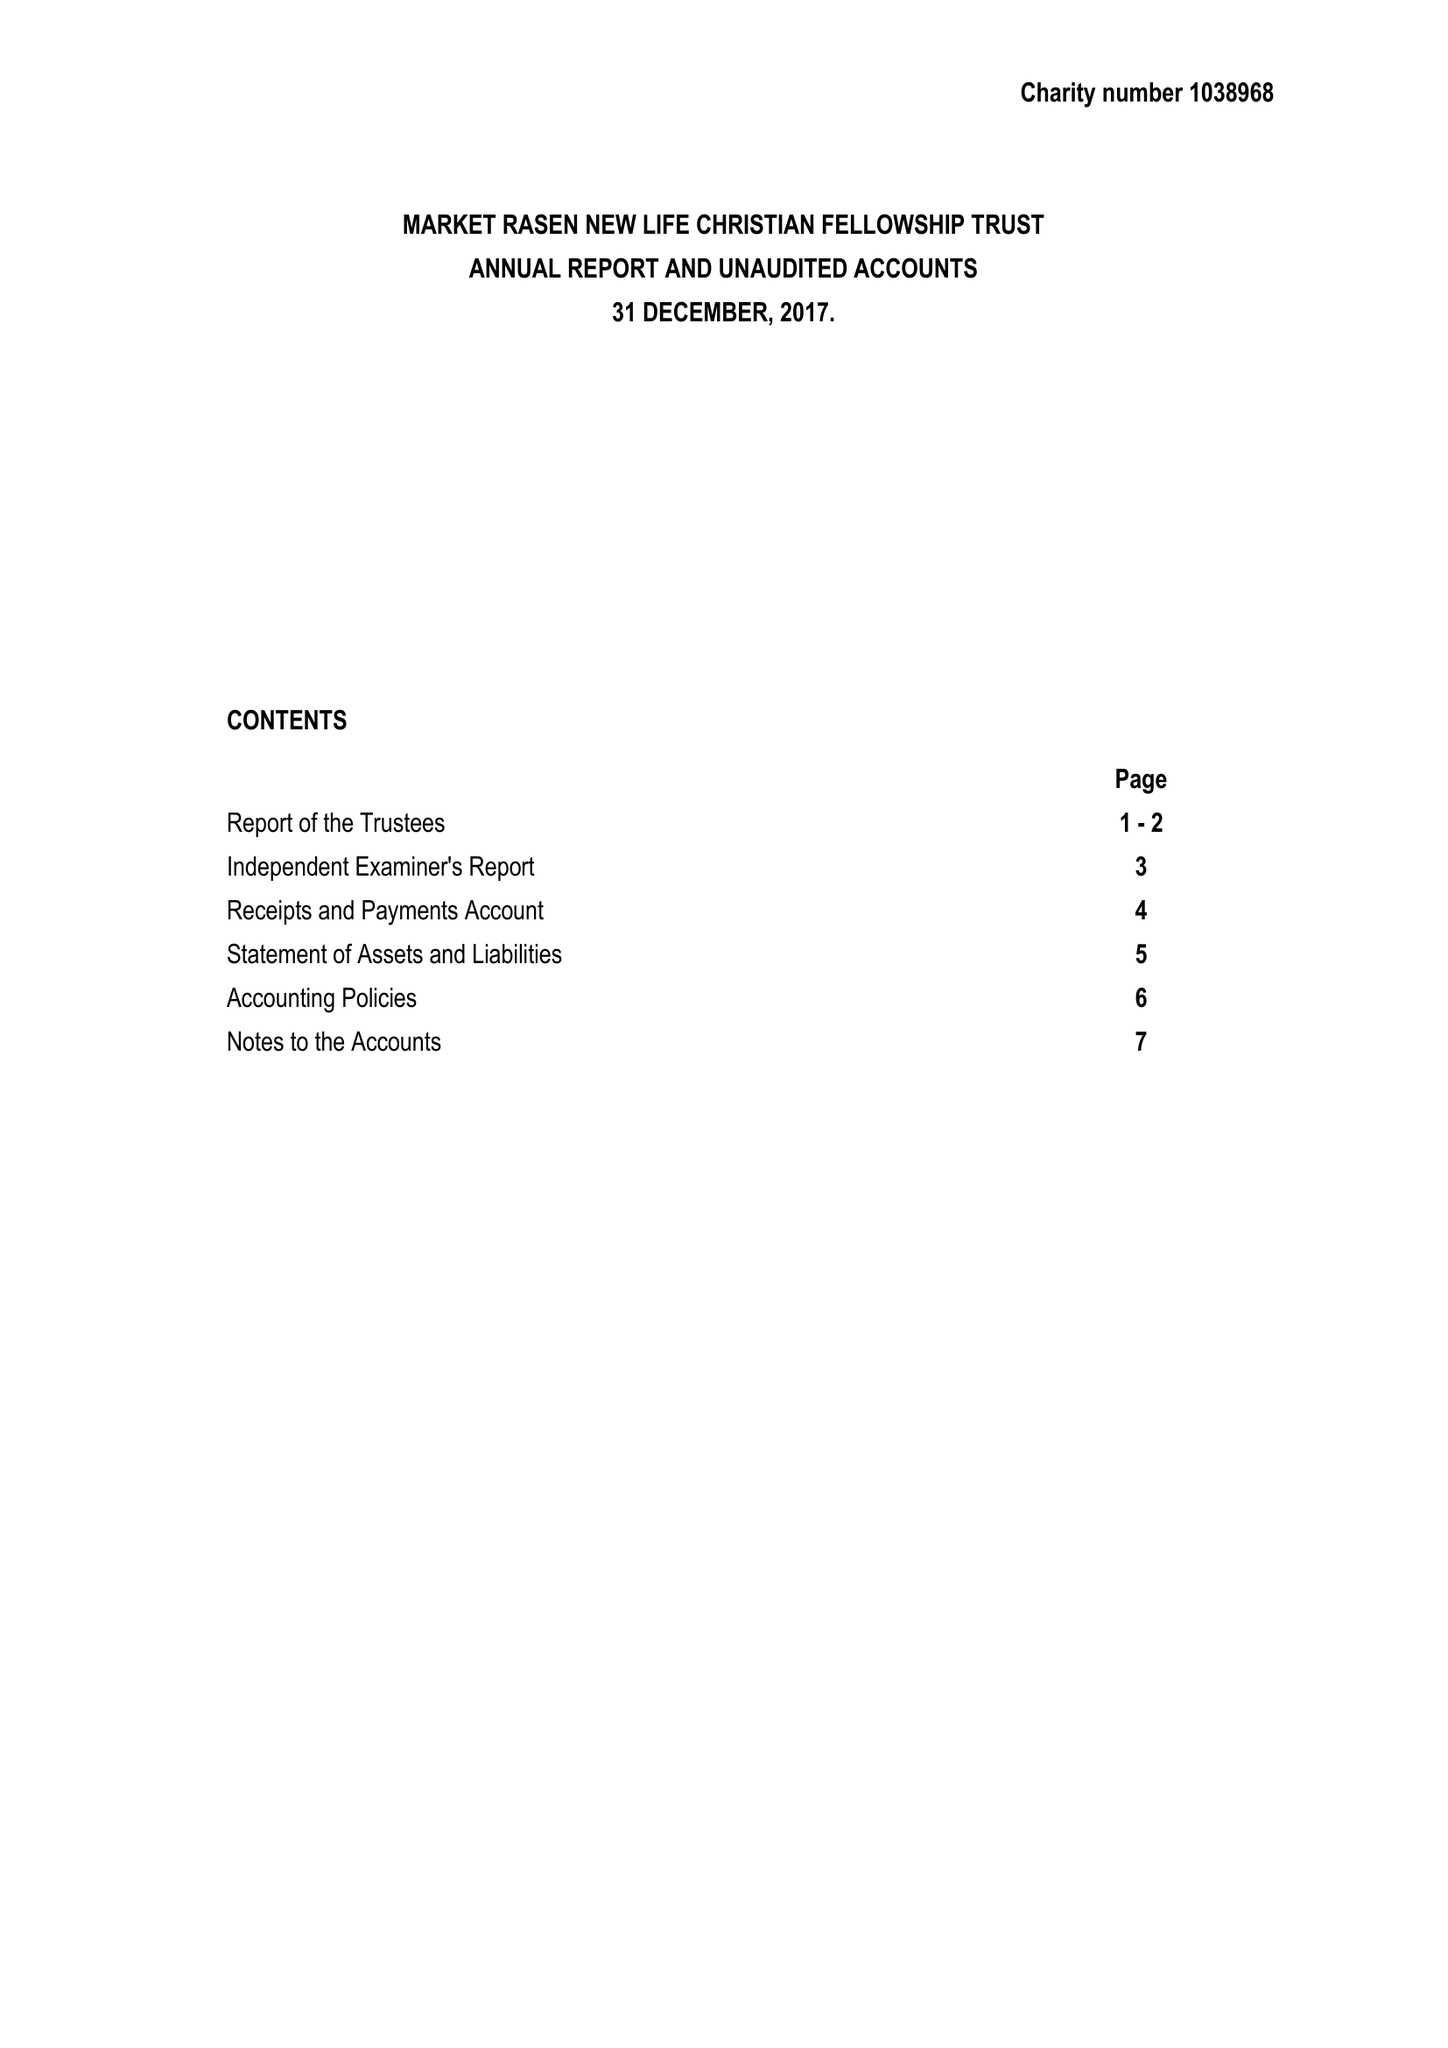What is the value for the report_date?
Answer the question using a single word or phrase. 2017-12-31 